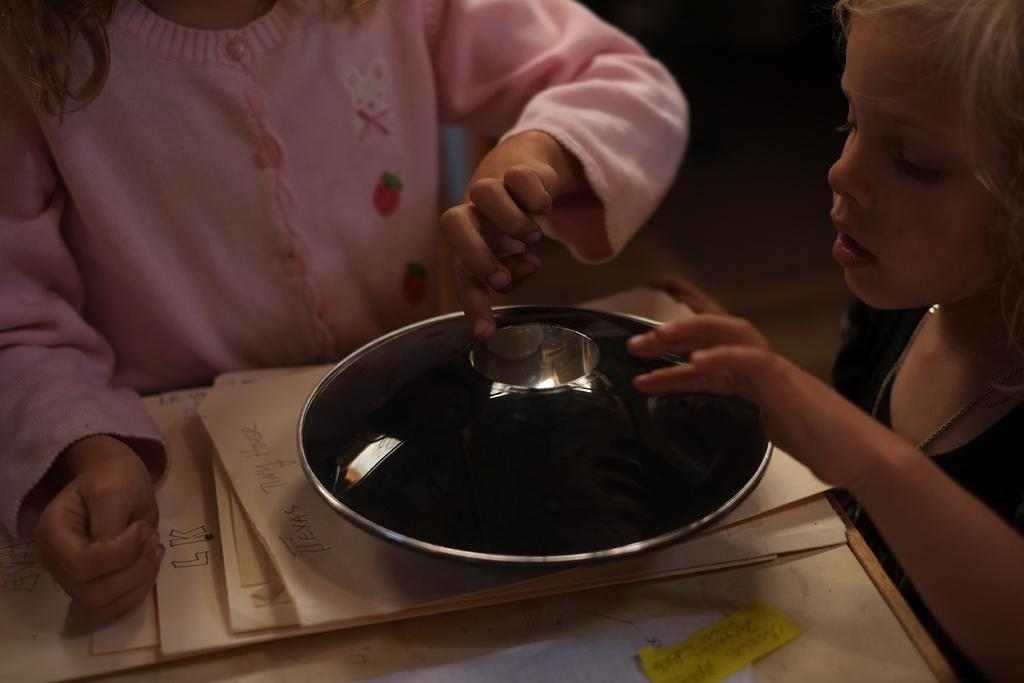What can be seen in the image? There are people and objects visible in the image. Can you describe the people in the image? Unfortunately, the provided facts do not offer any specific details about the people in the image. What types of objects can be seen in the image? Unfortunately, the provided facts do not offer any specific details about the objects in the image. What type of grass is growing in the image? There is no grass visible in the image. What kind of advertisement can be seen in the image? There is no advertisement present in the image. What is the zephyr doing in the image? There is no zephyr present in the image. 